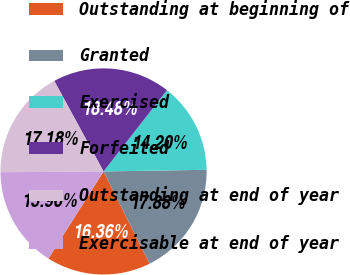Convert chart. <chart><loc_0><loc_0><loc_500><loc_500><pie_chart><fcel>Outstanding at beginning of<fcel>Granted<fcel>Exercised<fcel>Forfeited<fcel>Outstanding at end of year<fcel>Exercisable at end of year<nl><fcel>16.36%<fcel>17.88%<fcel>14.2%<fcel>18.48%<fcel>17.18%<fcel>15.9%<nl></chart> 